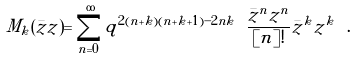Convert formula to latex. <formula><loc_0><loc_0><loc_500><loc_500>M _ { k } ( \bar { z } z ) = \sum ^ { \infty } _ { n = 0 } q ^ { 2 ( n + k ) ( n + k + 1 ) - 2 n k } \ \frac { \bar { z } ^ { n } z ^ { n } } { [ n ] ! } \bar { z } ^ { k } z ^ { k } \ .</formula> 